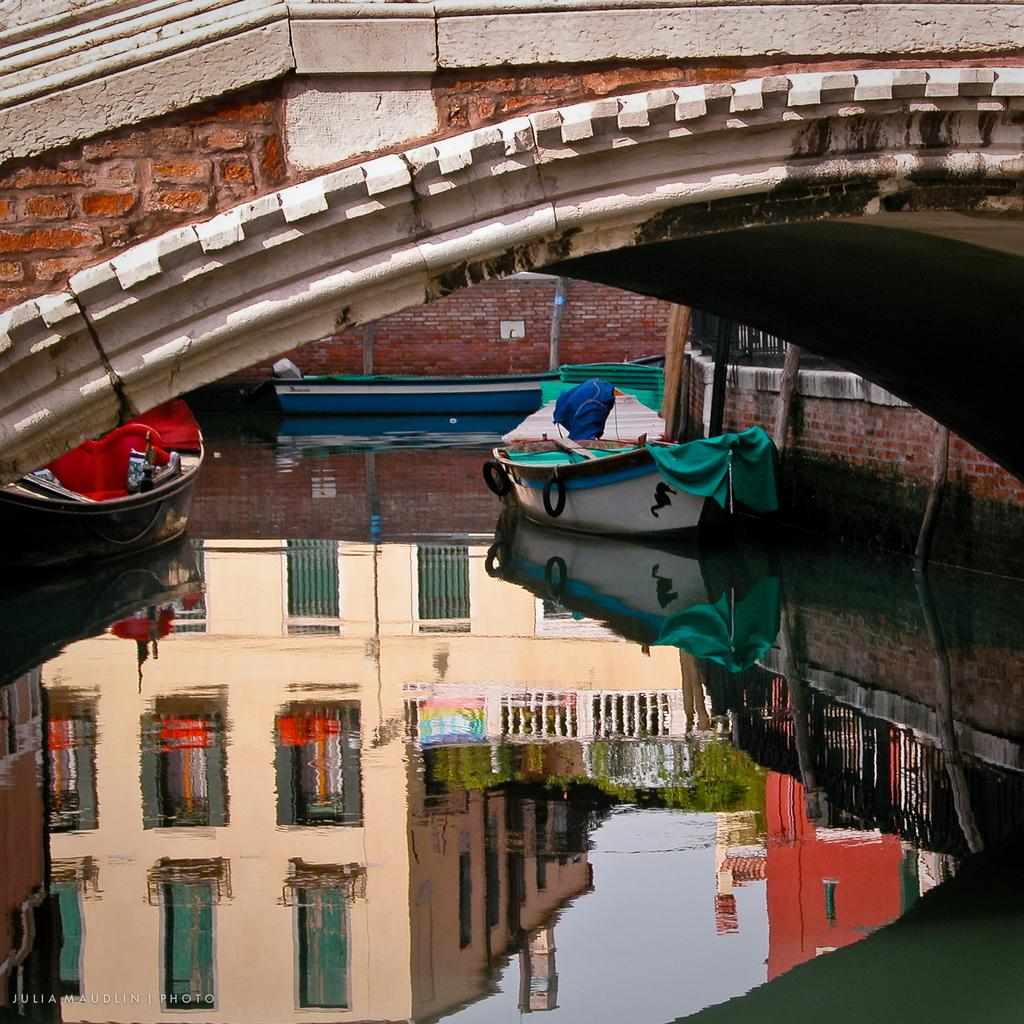What type of vehicles can be seen on the water in the image? There are boats present on the water in the image. What structure is visible at the top of the image? There is a bridge at the top of the image. What can be found at the bottom of the image? There is a logo at the bottom of the image. What type of education is being taught in the image? There is no indication of education in the image; it features boats on the water, a bridge, and a logo. What time of day is depicted in the image? The time of day is not specified in the image; it could be day or night based on the available information. 